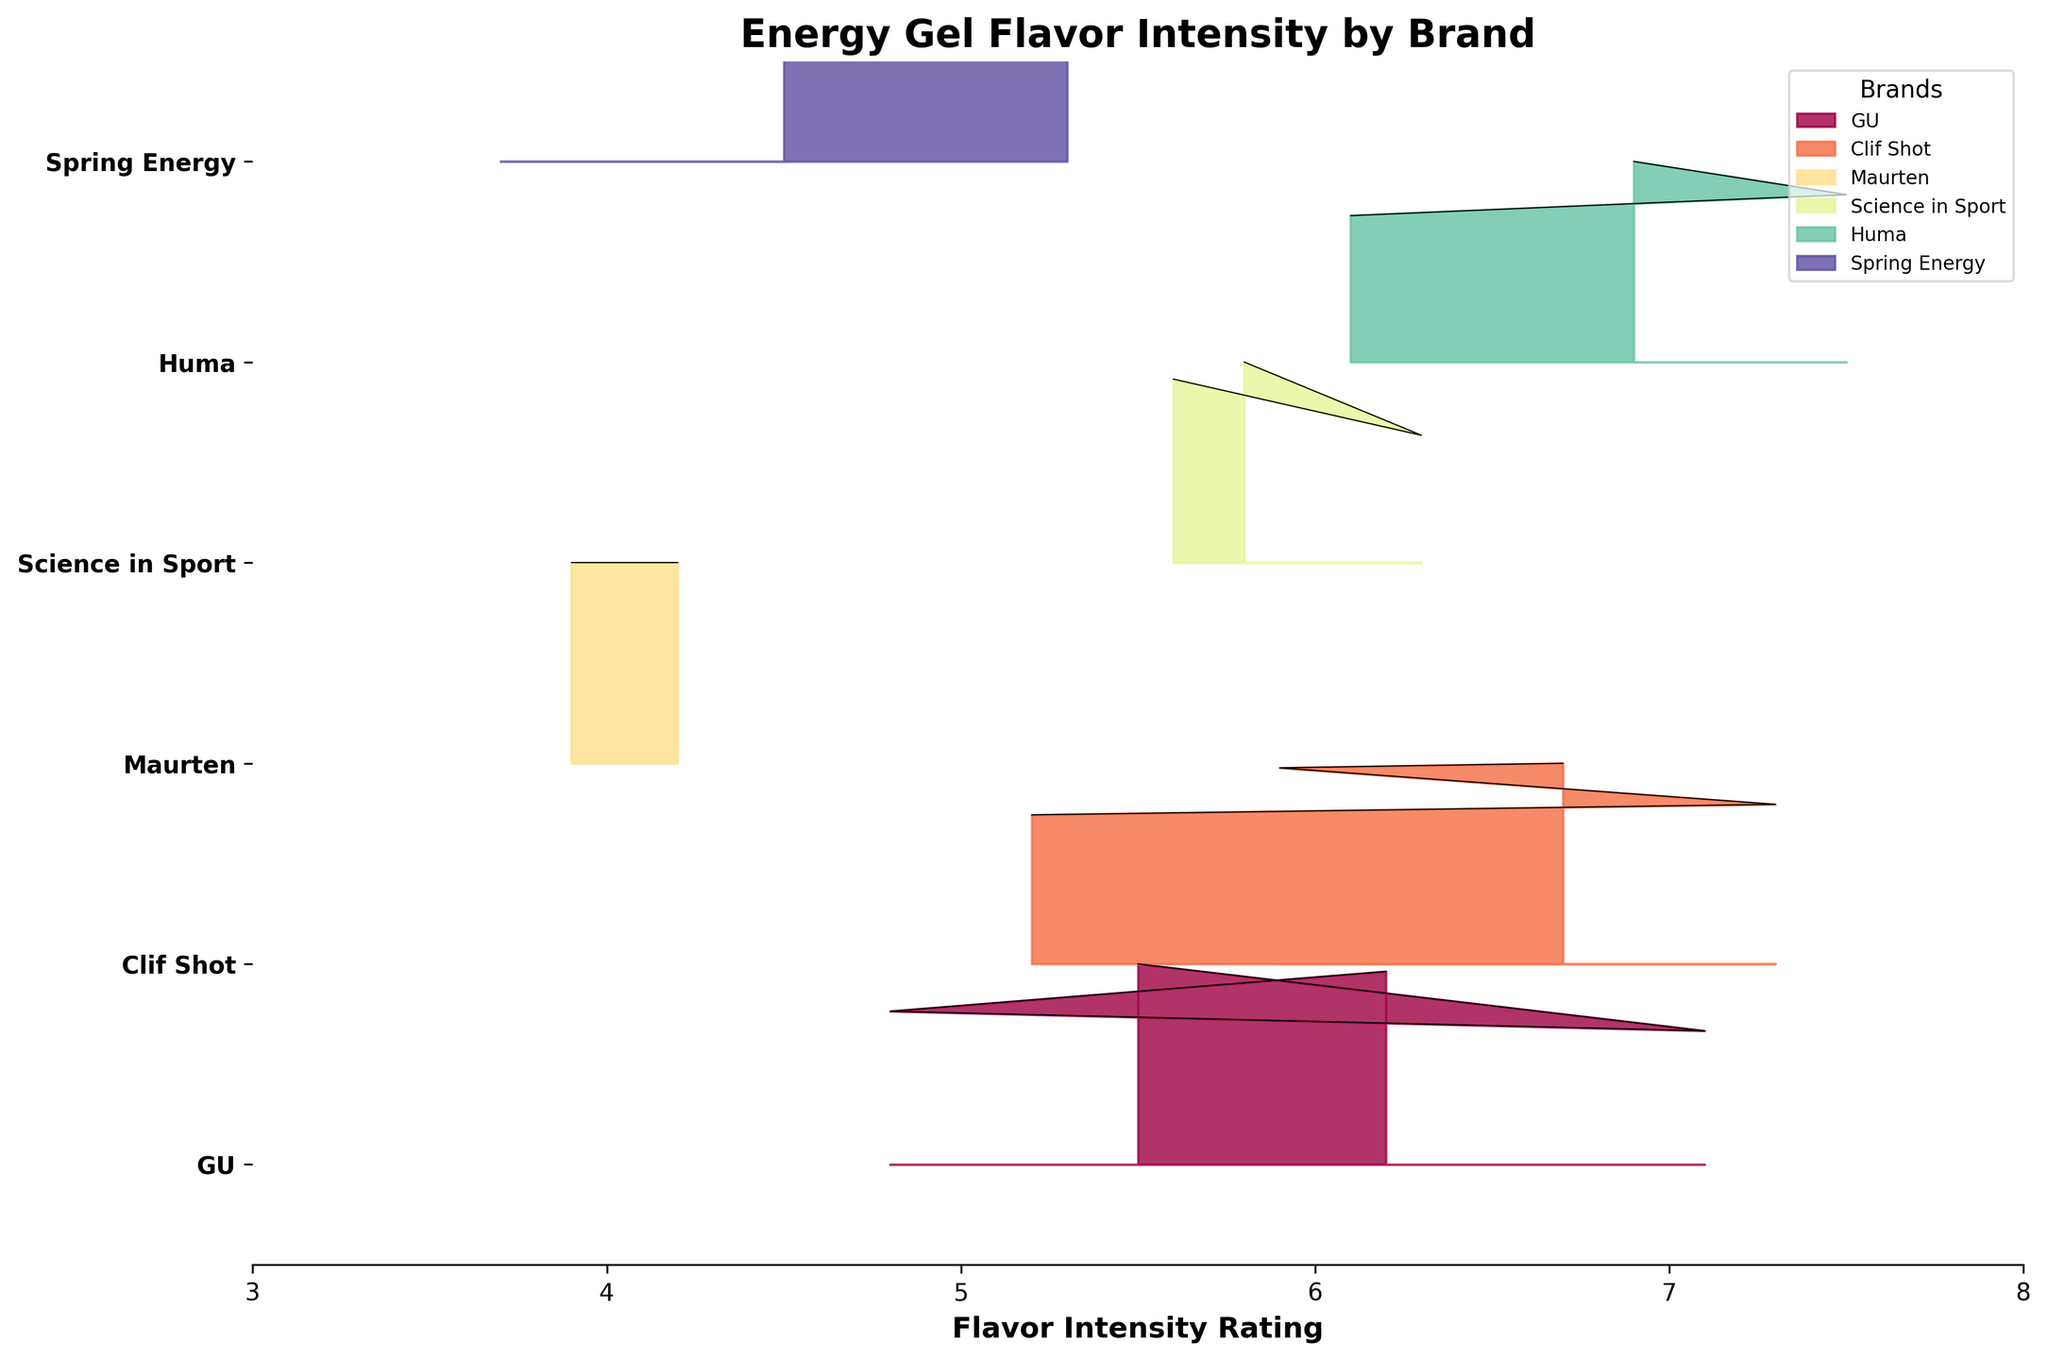What is the title of the figure? The title of the figure can be found at the top, centered text in a larger font size.
Answer: Energy Gel Flavor Intensity by Brand How many brands are represented in the figure? By looking at the y-axis, each tick corresponds to a different brand. Count the ticks.
Answer: 5 Which brand has the highest flavor intensity rating median? To find the brand with the highest median intensity rating, look for the brand whose density curve peaks at the highest flavor intensity rating.
Answer: Huma What is the range of flavor intensity ratings for GU? Identify the minimum and maximum intensity ratings along the x-axis where GU's density curve spans.
Answer: 4.8 to 7.1 Which flavor has the lowest flavor intensity rating among all brands? The lowest point on the x-axis where any of the density curves appear corresponds to the lowest intensity rating.
Answer: Long Haul by Spring Energy Between Clif Shot and Science in Sport, which brand has a higher flavor intensity rating median? Compare the peaks of the density curves for Clif Shot and Science in Sport. The brand with the higher peak median will be the higher one.
Answer: Clif Shot What is the average of the highest intensity ratings found across all brands? Identify the highest intensity ratings for each brand and compute their average. The highest ratings for GU, Clif Shot, Maurten, Science in Sport, and Huma are 7.1, 7.3, 4.2, 6.3, and 7.5 respectively. Calculate: (7.1+7.3+4.2+6.3+7.5)/5
Answer: 6.48 Which brand shows greater variation in flavor intensity, Science in Sport or Maurten? Greater spread of the density curve indicates higher variation. Compare the width of the curves for Science in Sport and Maurten.
Answer: Science in Sport What is the common x-axis range displayed in the figure? The horizontal limits of the plot show the range of x-axis values for flavor intensity ratings.
Answer: 3 to 8 Is there any overlap in flavor intensity ratings between GU and Huma? Check if the density curves of GU and Huma intersect or span any common x-axis values.
Answer: Yes 